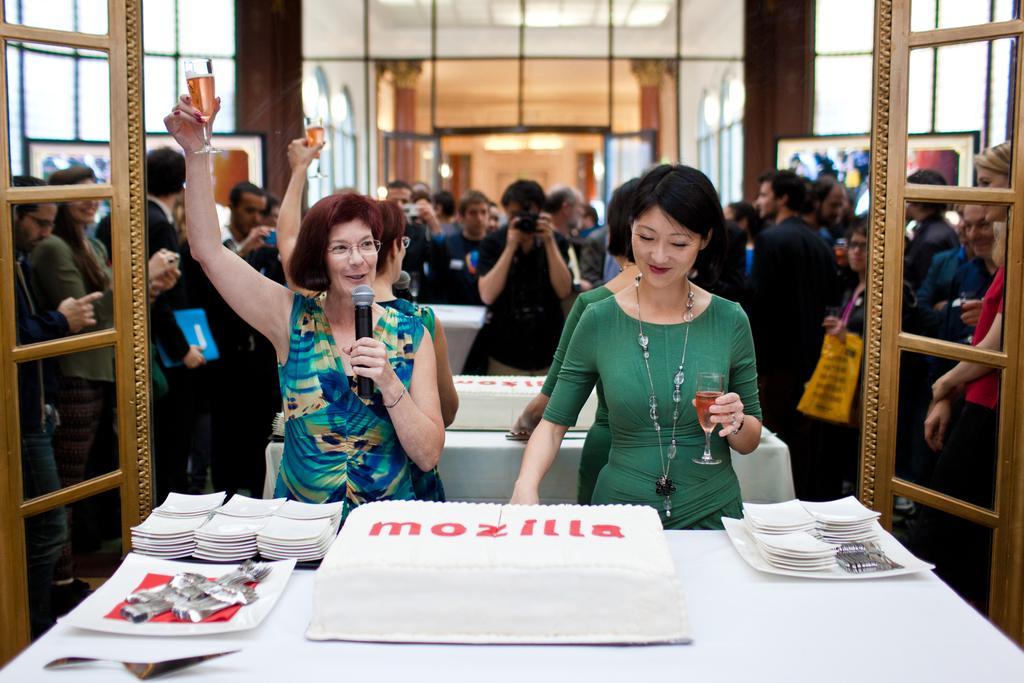Describe this image in one or two sentences. In this image in the front there is a table, on the table there are plates and spoons, there are persons standing and smiling. In the background there is a mirror in which there is reflection of the persons. In the center there is a woman standing and cutting a cake and holding a glass along with her and having smile on her face and there is a woman standing and holding mic and a glass in her hands and speaking and there is a reflection of the person standing and clicking a photo holding a camera in his hand and there are objects reflecting in the mirror. 